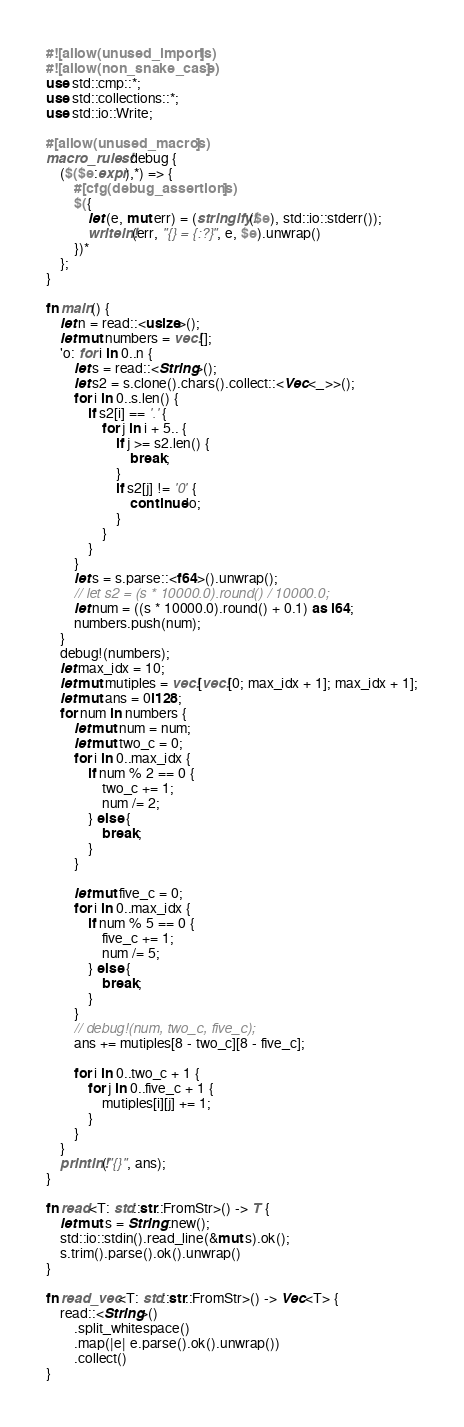<code> <loc_0><loc_0><loc_500><loc_500><_Rust_>#![allow(unused_imports)]
#![allow(non_snake_case)]
use std::cmp::*;
use std::collections::*;
use std::io::Write;

#[allow(unused_macros)]
macro_rules! debug {
    ($($e:expr),*) => {
        #[cfg(debug_assertions)]
        $({
            let (e, mut err) = (stringify!($e), std::io::stderr());
            writeln!(err, "{} = {:?}", e, $e).unwrap()
        })*
    };
}

fn main() {
    let n = read::<usize>();
    let mut numbers = vec![];
    'o: for i in 0..n {
        let s = read::<String>();
        let s2 = s.clone().chars().collect::<Vec<_>>();
        for i in 0..s.len() {
            if s2[i] == '.' {
                for j in i + 5.. {
                    if j >= s2.len() {
                        break;
                    }
                    if s2[j] != '0' {
                        continue 'o;
                    }
                }
            }
        }
        let s = s.parse::<f64>().unwrap();
        // let s2 = (s * 10000.0).round() / 10000.0;
        let num = ((s * 10000.0).round() + 0.1) as i64;
        numbers.push(num);
    }
    debug!(numbers);
    let max_idx = 10;
    let mut mutiples = vec![vec![0; max_idx + 1]; max_idx + 1];
    let mut ans = 0i128;
    for num in numbers {
        let mut num = num;
        let mut two_c = 0;
        for i in 0..max_idx {
            if num % 2 == 0 {
                two_c += 1;
                num /= 2;
            } else {
                break;
            }
        }

        let mut five_c = 0;
        for i in 0..max_idx {
            if num % 5 == 0 {
                five_c += 1;
                num /= 5;
            } else {
                break;
            }
        }
        // debug!(num, two_c, five_c);
        ans += mutiples[8 - two_c][8 - five_c];

        for i in 0..two_c + 1 {
            for j in 0..five_c + 1 {
                mutiples[i][j] += 1;
            }
        }
    }
    println!("{}", ans);
}

fn read<T: std::str::FromStr>() -> T {
    let mut s = String::new();
    std::io::stdin().read_line(&mut s).ok();
    s.trim().parse().ok().unwrap()
}

fn read_vec<T: std::str::FromStr>() -> Vec<T> {
    read::<String>()
        .split_whitespace()
        .map(|e| e.parse().ok().unwrap())
        .collect()
}
</code> 